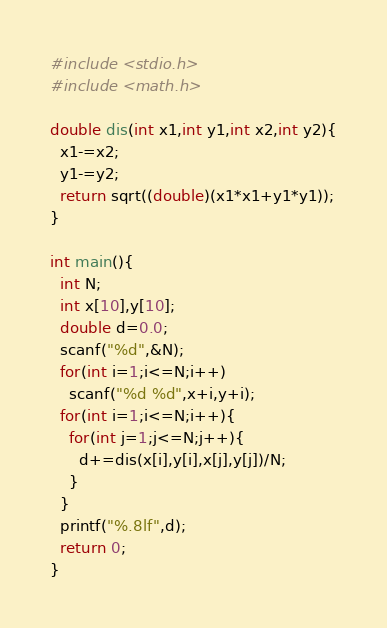<code> <loc_0><loc_0><loc_500><loc_500><_C_>#include <stdio.h>
#include <math.h>

double dis(int x1,int y1,int x2,int y2){
  x1-=x2;
  y1-=y2;
  return sqrt((double)(x1*x1+y1*y1));
}

int main(){
  int N;
  int x[10],y[10];
  double d=0.0;
  scanf("%d",&N);
  for(int i=1;i<=N;i++)
    scanf("%d %d",x+i,y+i);
  for(int i=1;i<=N;i++){
    for(int j=1;j<=N;j++){
      d+=dis(x[i],y[i],x[j],y[j])/N;
    }
  }
  printf("%.8lf",d);
  return 0;
}</code> 